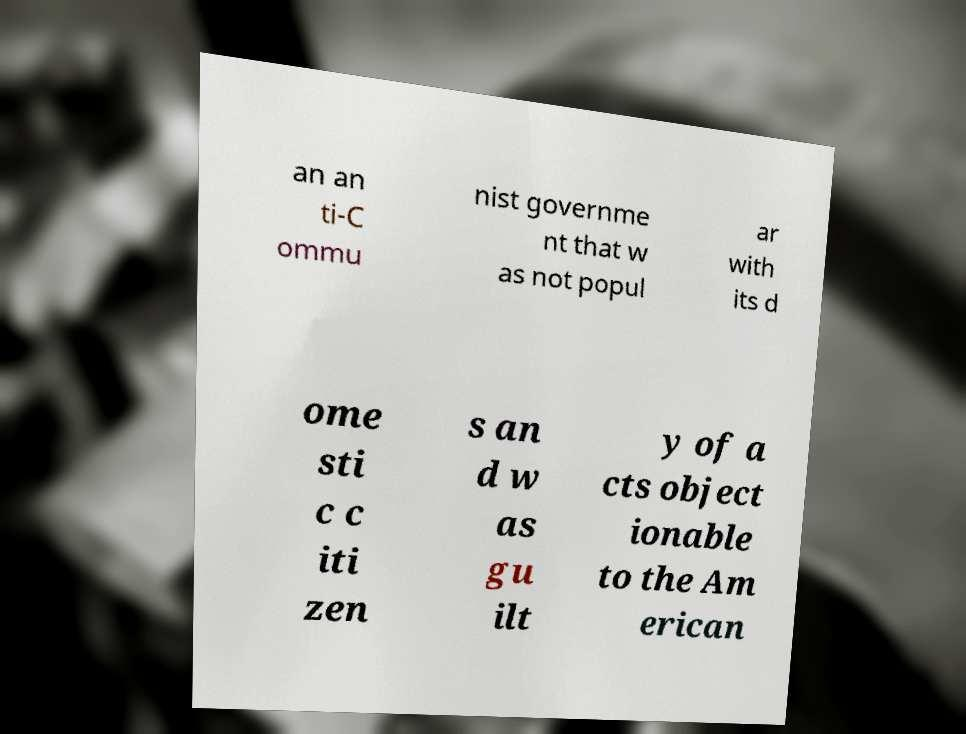Please read and relay the text visible in this image. What does it say? an an ti-C ommu nist governme nt that w as not popul ar with its d ome sti c c iti zen s an d w as gu ilt y of a cts object ionable to the Am erican 